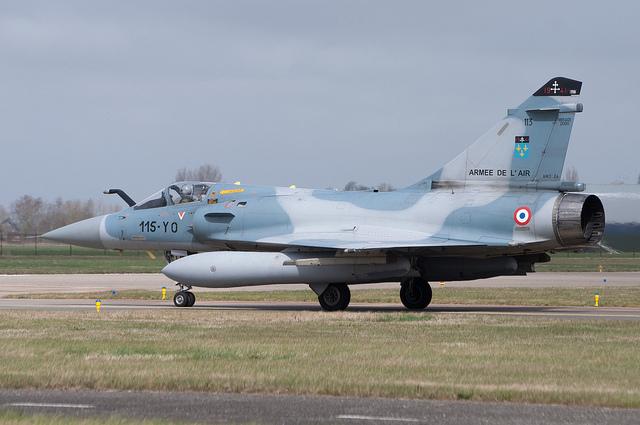How many airplanes are there?
Write a very short answer. 1. Is the front of plane pointy or flat?
Concise answer only. Pointy. What letters are on the plane?
Keep it brief. You. What numbers are on the front of the plane?
Answer briefly. 115. Is this a war?
Write a very short answer. No. 